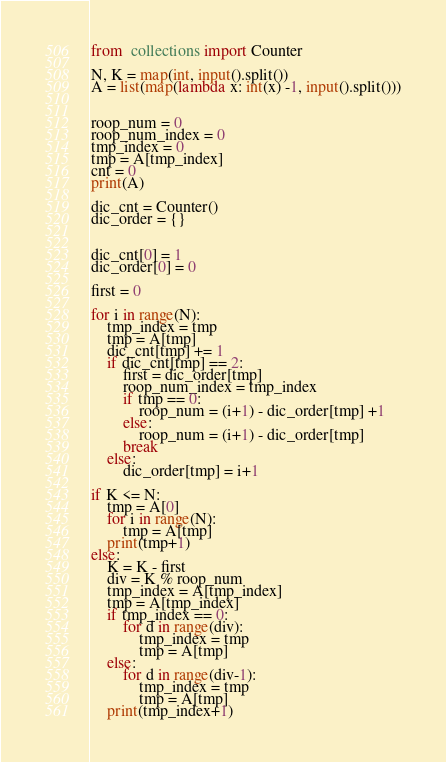Convert code to text. <code><loc_0><loc_0><loc_500><loc_500><_Python_>from  collections import Counter

N, K = map(int, input().split())
A = list(map(lambda x: int(x) -1, input().split()))


roop_num = 0
roop_num_index = 0
tmp_index = 0
tmp = A[tmp_index]
cnt = 0
print(A)

dic_cnt = Counter()
dic_order = {}


dic_cnt[0] = 1
dic_order[0] = 0

first = 0

for i in range(N):
    tmp_index = tmp
    tmp = A[tmp]
    dic_cnt[tmp] += 1
    if dic_cnt[tmp] == 2:
        first = dic_order[tmp]
        roop_num_index = tmp_index
        if tmp == 0:
            roop_num = (i+1) - dic_order[tmp] +1
        else:    
            roop_num = (i+1) - dic_order[tmp]
        break
    else:
        dic_order[tmp] = i+1

if K <= N:
    tmp = A[0]
    for i in range(N):
        tmp = A[tmp]
    print(tmp+1)
else:
    K = K - first
    div = K % roop_num
    tmp_index = A[tmp_index]
    tmp = A[tmp_index]
    if tmp_index == 0:
        for d in range(div):
            tmp_index = tmp
            tmp = A[tmp]
    else:
        for d in range(div-1):
            tmp_index = tmp
            tmp = A[tmp]
    print(tmp_index+1)



</code> 